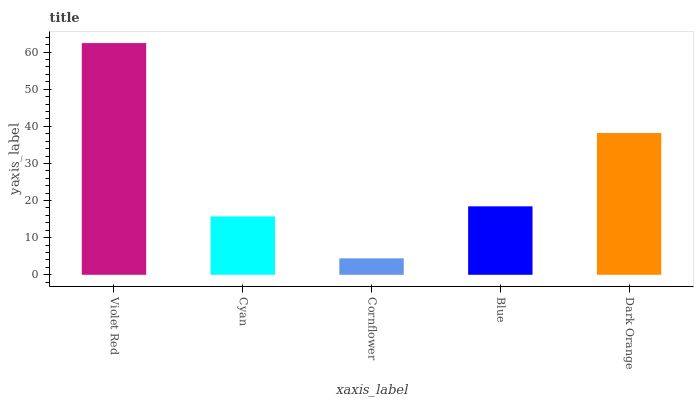Is Cyan the minimum?
Answer yes or no. No. Is Cyan the maximum?
Answer yes or no. No. Is Violet Red greater than Cyan?
Answer yes or no. Yes. Is Cyan less than Violet Red?
Answer yes or no. Yes. Is Cyan greater than Violet Red?
Answer yes or no. No. Is Violet Red less than Cyan?
Answer yes or no. No. Is Blue the high median?
Answer yes or no. Yes. Is Blue the low median?
Answer yes or no. Yes. Is Cornflower the high median?
Answer yes or no. No. Is Cyan the low median?
Answer yes or no. No. 